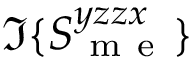Convert formula to latex. <formula><loc_0><loc_0><loc_500><loc_500>\Im \{ S _ { m e } ^ { y z z x } \}</formula> 